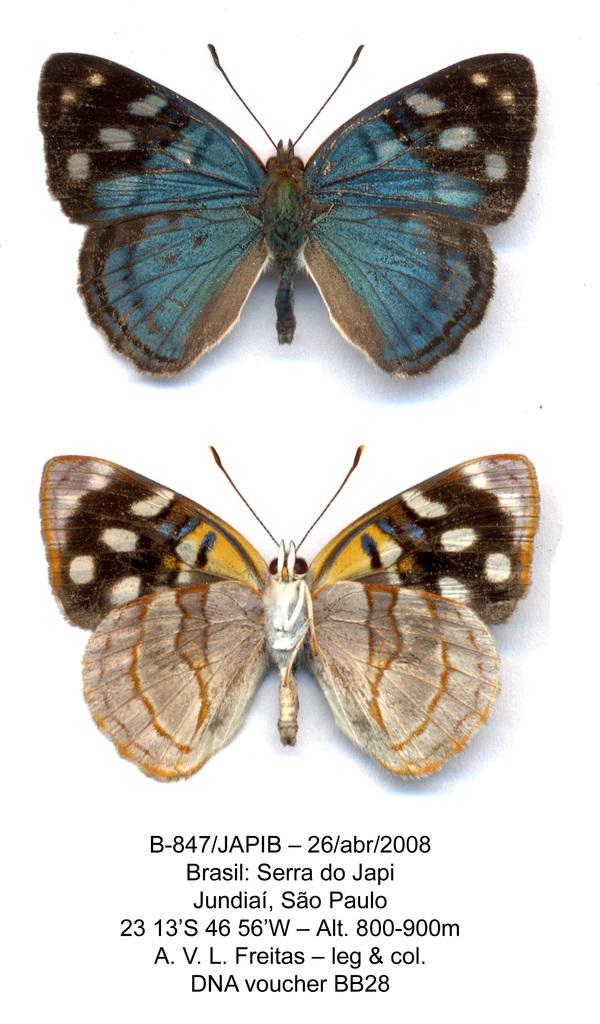How many butterflies are present in the image? There are two butterflies in the image. What can be found in addition to the butterflies in the image? There is something written on the image. What rhythm is the bucket following in the image? There is no bucket present in the image, so it cannot be following any rhythm. 